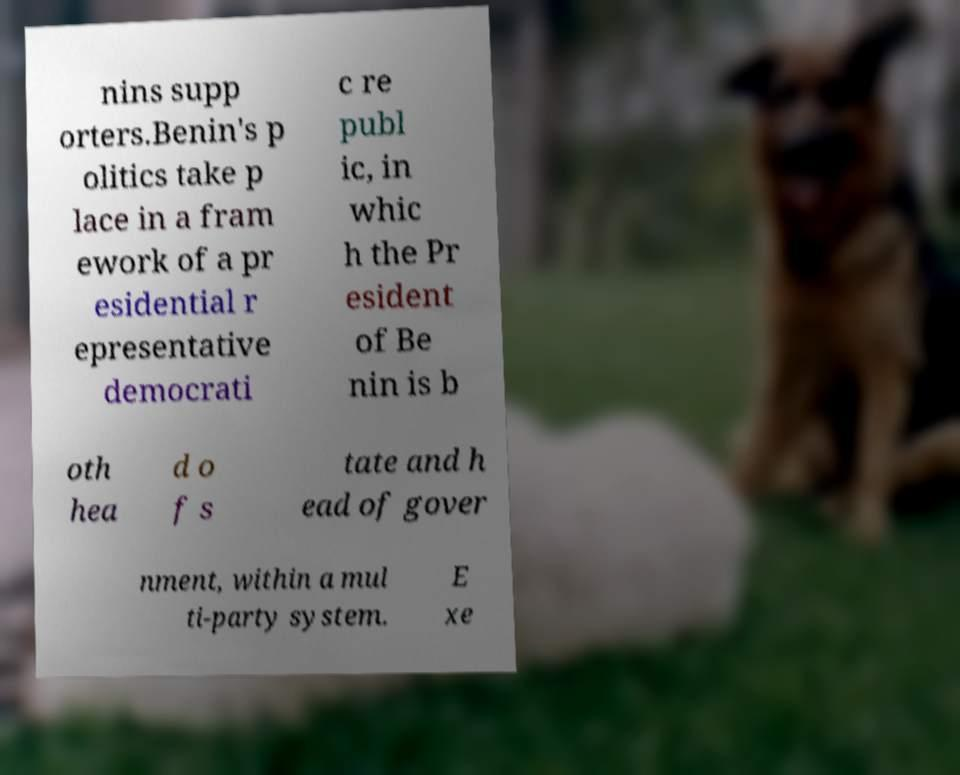What messages or text are displayed in this image? I need them in a readable, typed format. nins supp orters.Benin's p olitics take p lace in a fram ework of a pr esidential r epresentative democrati c re publ ic, in whic h the Pr esident of Be nin is b oth hea d o f s tate and h ead of gover nment, within a mul ti-party system. E xe 